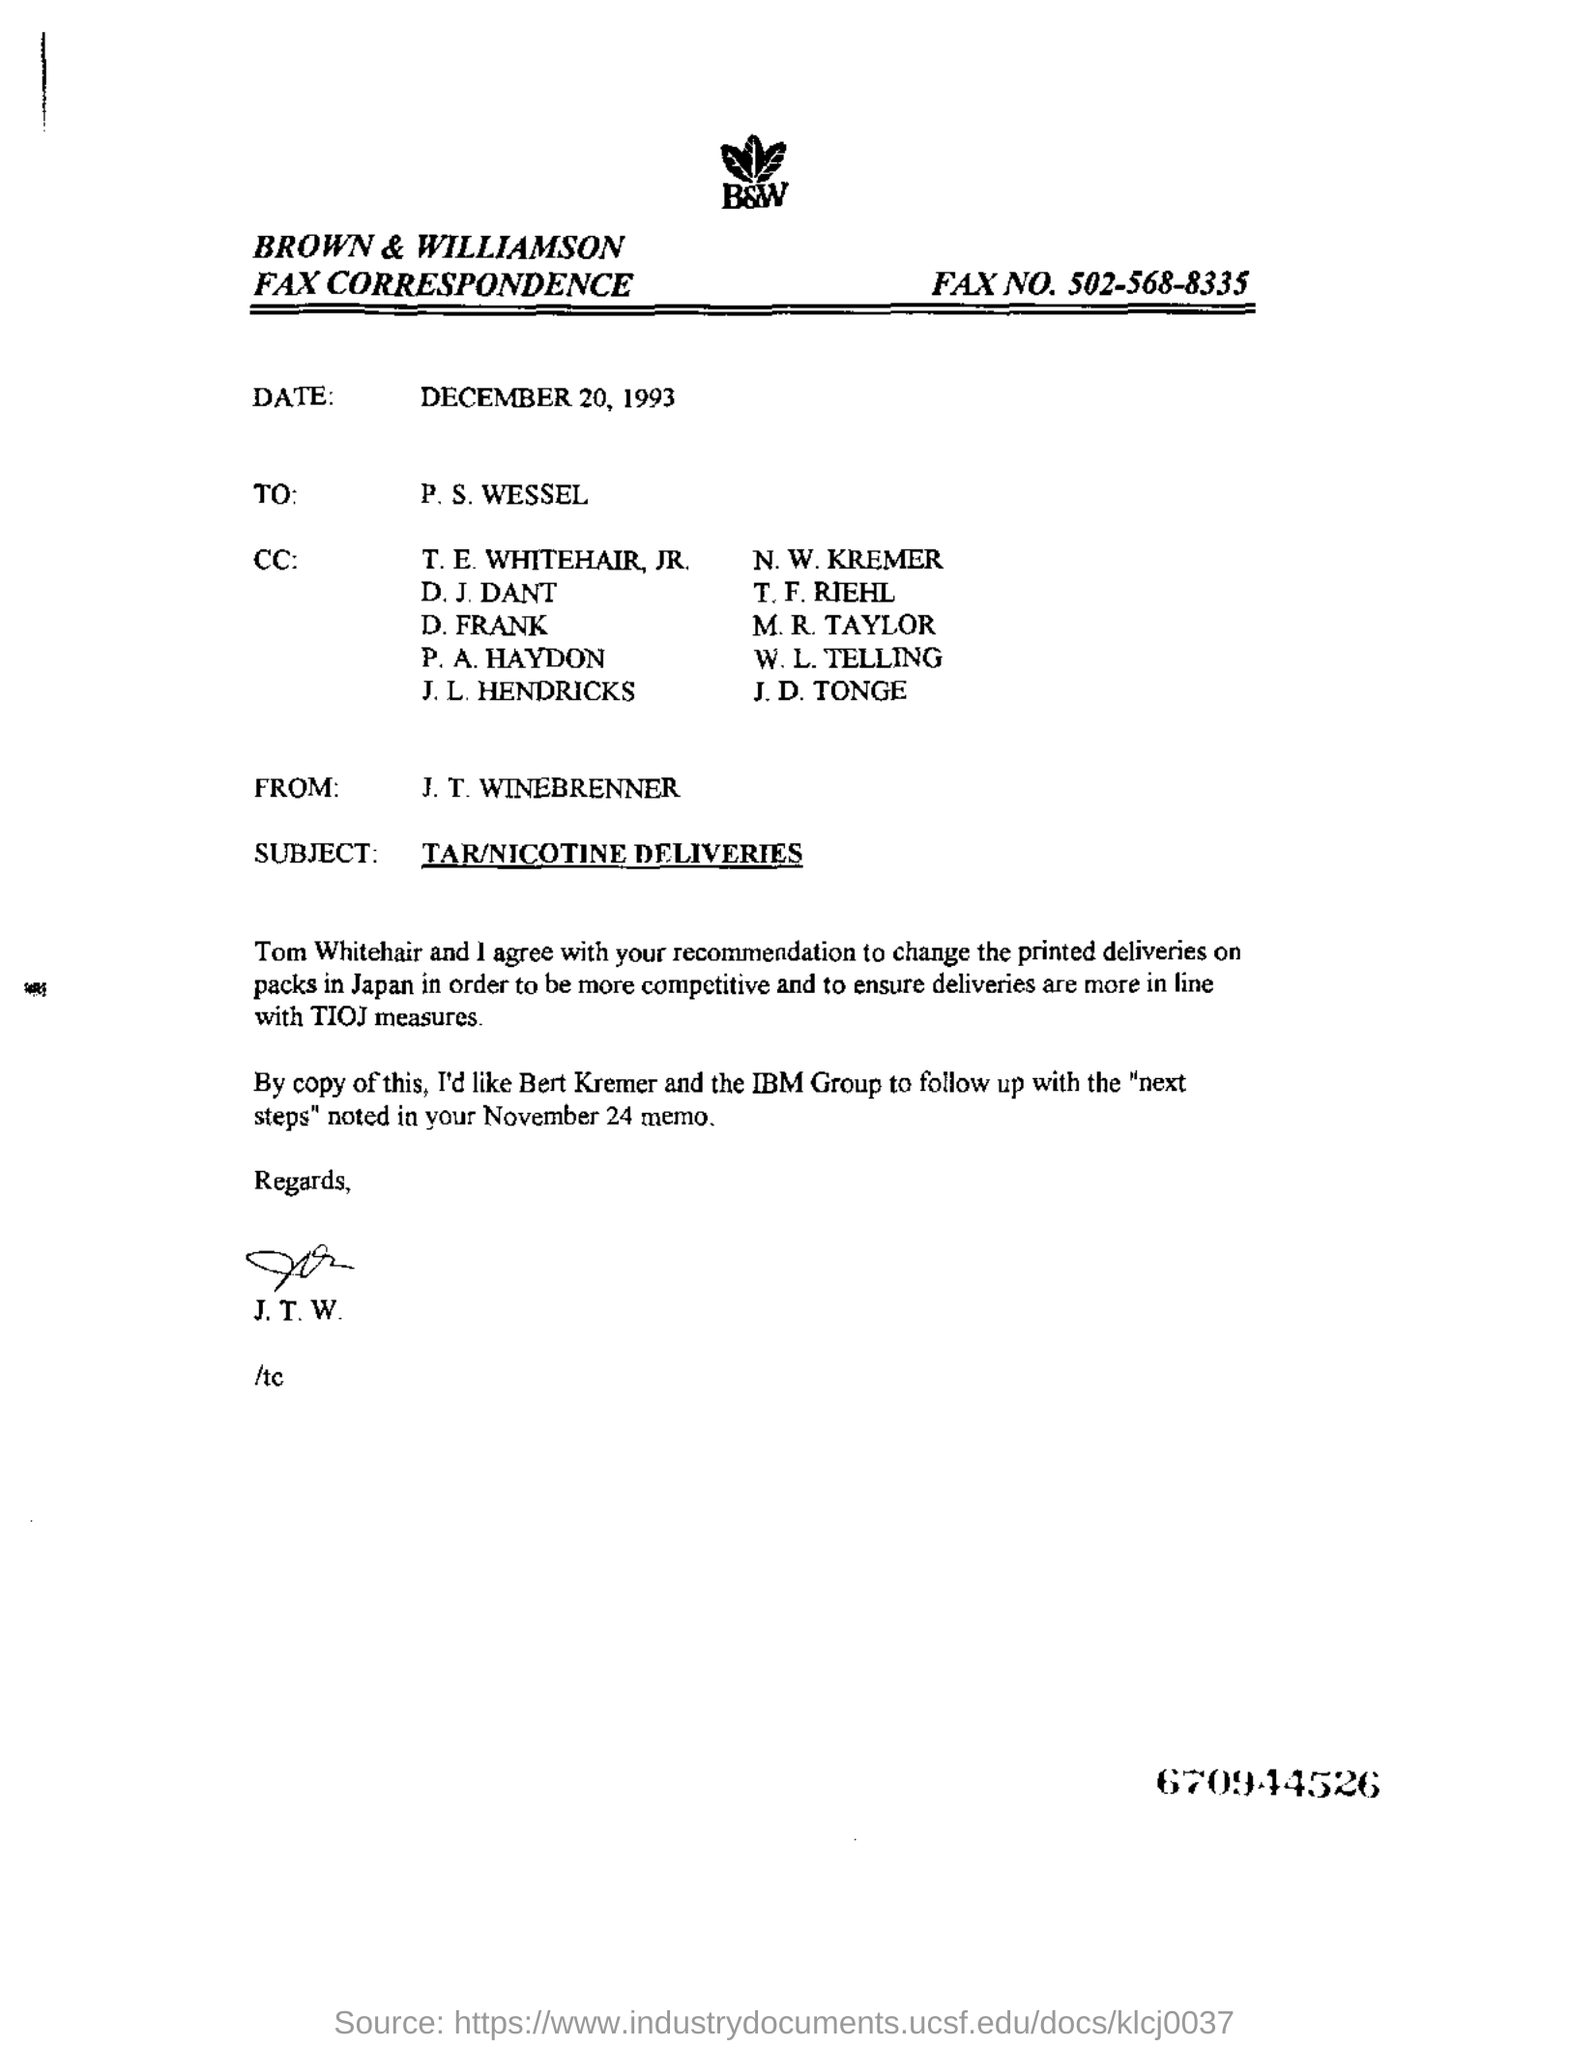What is the date mentioned?
Offer a very short reply. December 20, 1993. What is the subject of the email?
Provide a short and direct response. TAR/NICOTINE DELIVERIES. What is the name of the person in the "FROM" field?
Provide a succinct answer. J. T. WINEBRENNER. 